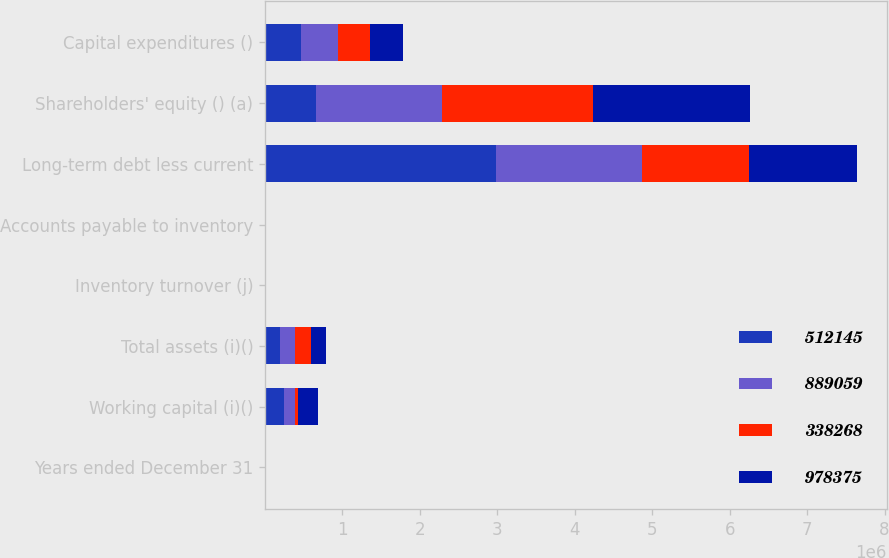Convert chart to OTSL. <chart><loc_0><loc_0><loc_500><loc_500><stacked_bar_chart><ecel><fcel>Years ended December 31<fcel>Working capital (i)()<fcel>Total assets (i)()<fcel>Inventory turnover (j)<fcel>Accounts payable to inventory<fcel>Long-term debt less current<fcel>Shareholders' equity () (a)<fcel>Capital expenditures ()<nl><fcel>512145<fcel>2017<fcel>249694<fcel>196184<fcel>1.4<fcel>106<fcel>2.97839e+06<fcel>653046<fcel>465940<nl><fcel>889059<fcel>2016<fcel>142674<fcel>196184<fcel>1.5<fcel>105.7<fcel>1.88702e+06<fcel>1.62714e+06<fcel>476344<nl><fcel>338268<fcel>2015<fcel>36372<fcel>196184<fcel>1.5<fcel>99.1<fcel>1.39002e+06<fcel>1.96131e+06<fcel>414020<nl><fcel>978375<fcel>2014<fcel>252082<fcel>196184<fcel>1.4<fcel>94.6<fcel>1.3884e+06<fcel>2.01842e+06<fcel>429987<nl></chart> 